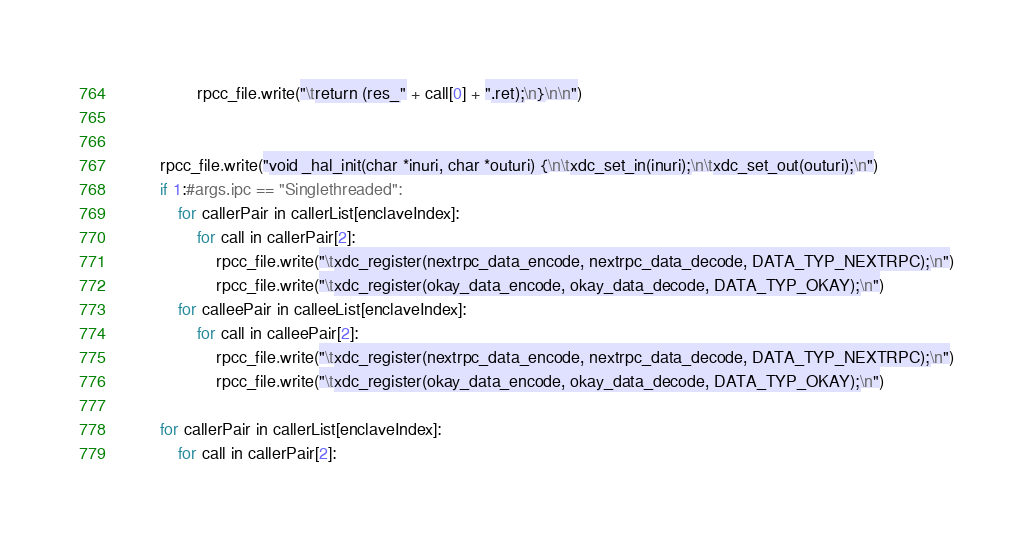<code> <loc_0><loc_0><loc_500><loc_500><_Python_>                rpcc_file.write("\treturn (res_" + call[0] + ".ret);\n}\n\n")

        
        rpcc_file.write("void _hal_init(char *inuri, char *outuri) {\n\txdc_set_in(inuri);\n\txdc_set_out(outuri);\n") 
        if 1:#args.ipc == "Singlethreaded":
            for callerPair in callerList[enclaveIndex]:
                for call in callerPair[2]:
                    rpcc_file.write("\txdc_register(nextrpc_data_encode, nextrpc_data_decode, DATA_TYP_NEXTRPC);\n")
                    rpcc_file.write("\txdc_register(okay_data_encode, okay_data_decode, DATA_TYP_OKAY);\n")
            for calleePair in calleeList[enclaveIndex]:
                for call in calleePair[2]:
                    rpcc_file.write("\txdc_register(nextrpc_data_encode, nextrpc_data_decode, DATA_TYP_NEXTRPC);\n")
                    rpcc_file.write("\txdc_register(okay_data_encode, okay_data_decode, DATA_TYP_OKAY);\n")
        
        for callerPair in callerList[enclaveIndex]:
            for call in callerPair[2]:</code> 